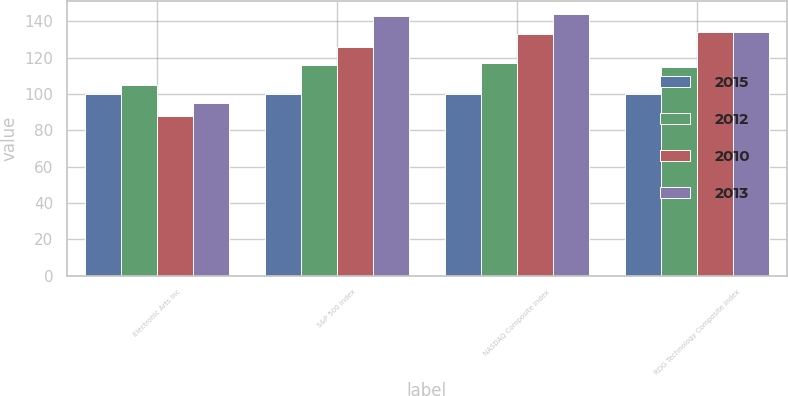Convert chart. <chart><loc_0><loc_0><loc_500><loc_500><stacked_bar_chart><ecel><fcel>Electronic Arts Inc<fcel>S&P 500 Index<fcel>NASDAQ Composite Index<fcel>RDG Technology Composite Index<nl><fcel>2015<fcel>100<fcel>100<fcel>100<fcel>100<nl><fcel>2012<fcel>105<fcel>116<fcel>117<fcel>115<nl><fcel>2010<fcel>88<fcel>126<fcel>133<fcel>134<nl><fcel>2013<fcel>95<fcel>143<fcel>144<fcel>134<nl></chart> 